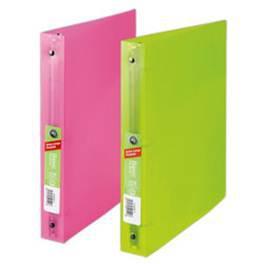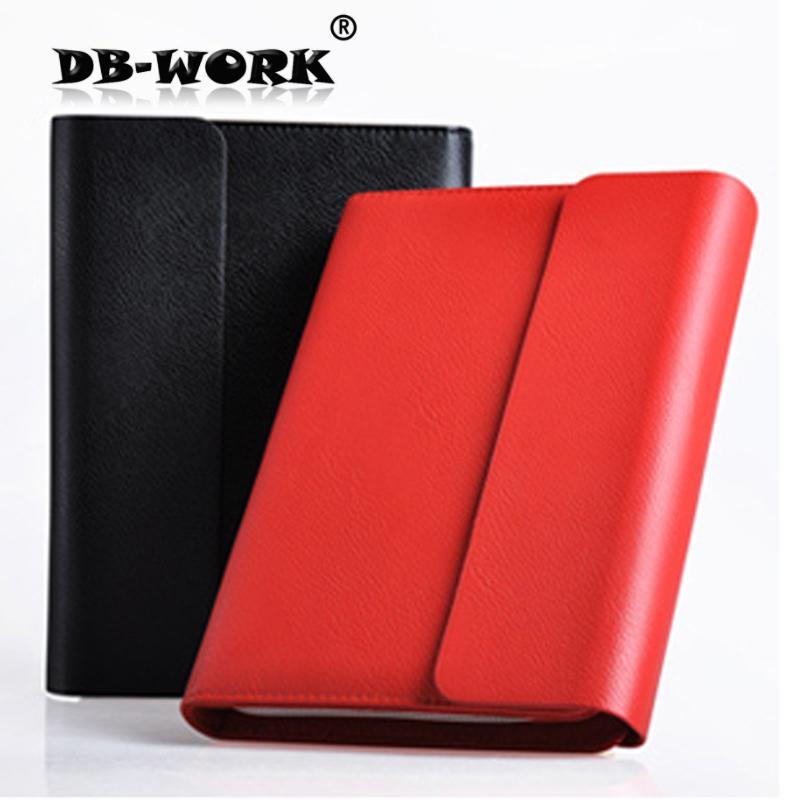The first image is the image on the left, the second image is the image on the right. For the images displayed, is the sentence "In total, four binders are shown." factually correct? Answer yes or no. Yes. 